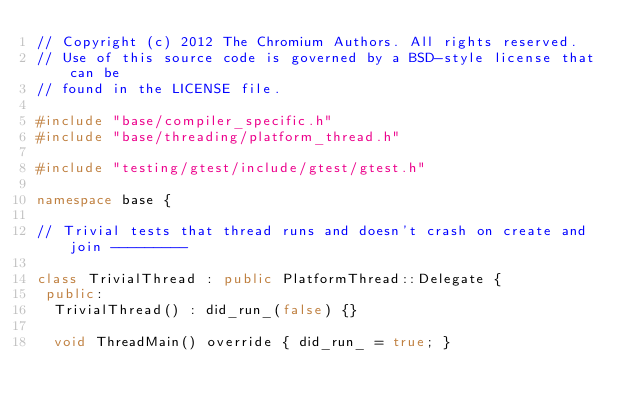<code> <loc_0><loc_0><loc_500><loc_500><_C++_>// Copyright (c) 2012 The Chromium Authors. All rights reserved.
// Use of this source code is governed by a BSD-style license that can be
// found in the LICENSE file.

#include "base/compiler_specific.h"
#include "base/threading/platform_thread.h"

#include "testing/gtest/include/gtest/gtest.h"

namespace base {

// Trivial tests that thread runs and doesn't crash on create and join ---------

class TrivialThread : public PlatformThread::Delegate {
 public:
  TrivialThread() : did_run_(false) {}

  void ThreadMain() override { did_run_ = true; }
</code> 